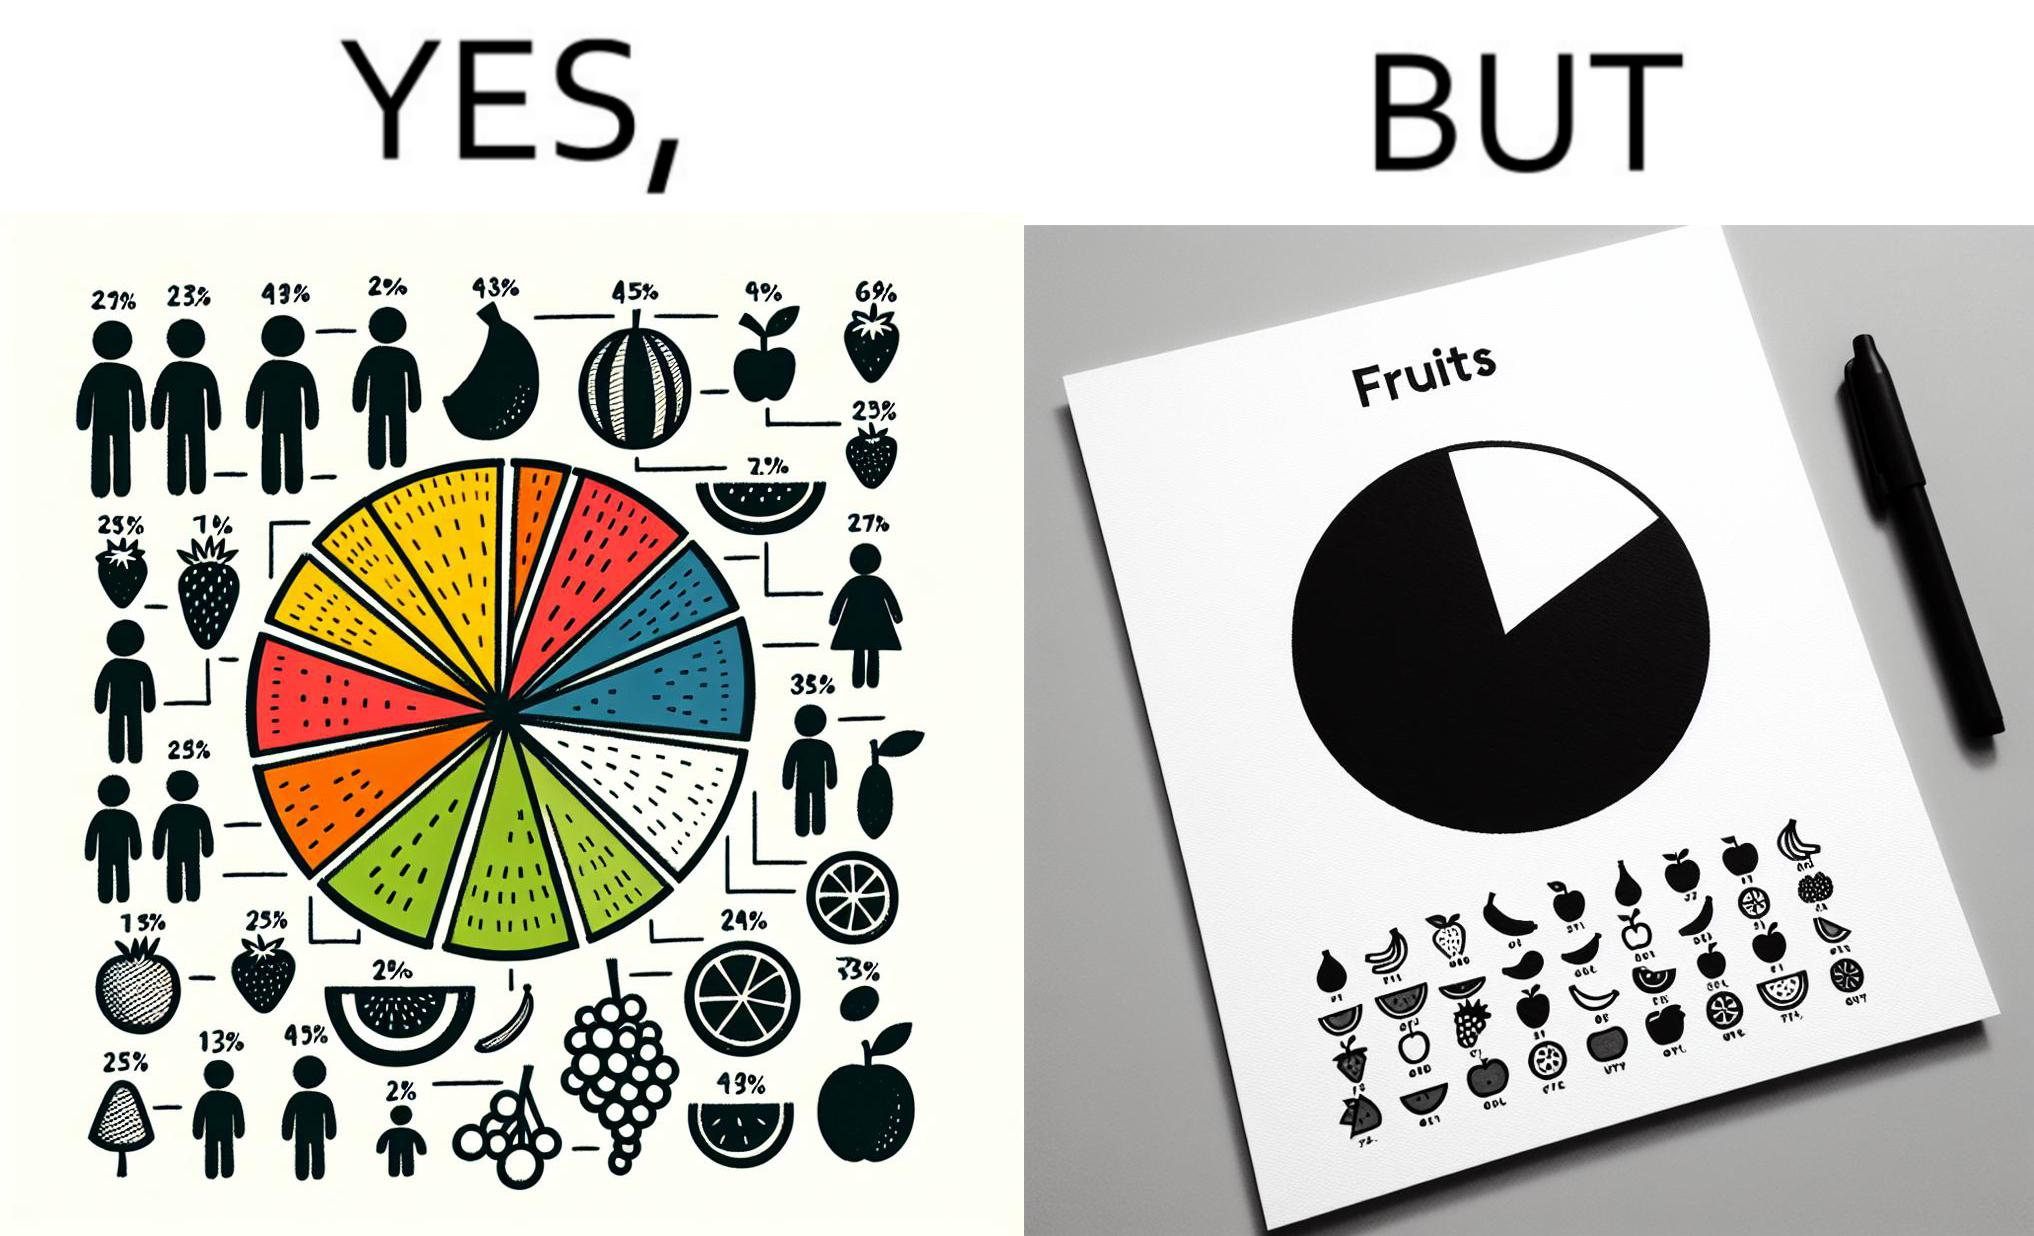Describe the satirical element in this image. This is funny because the pie chart printout is useless as you cant see any divisions on it because the  printer could not capture the different colors 